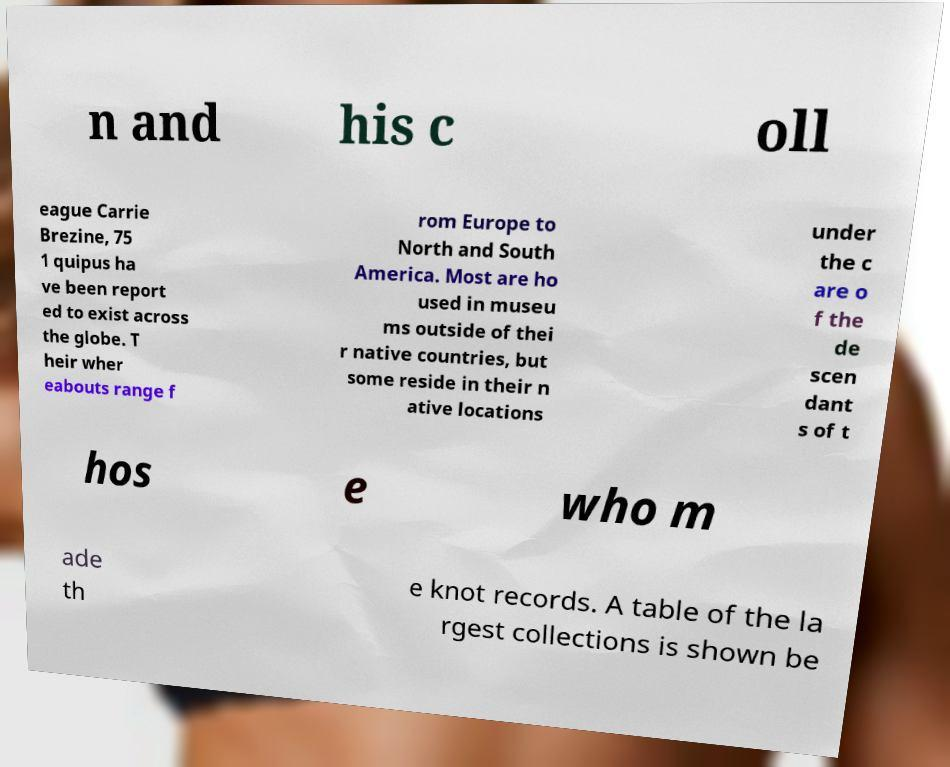Please identify and transcribe the text found in this image. n and his c oll eague Carrie Brezine, 75 1 quipus ha ve been report ed to exist across the globe. T heir wher eabouts range f rom Europe to North and South America. Most are ho used in museu ms outside of thei r native countries, but some reside in their n ative locations under the c are o f the de scen dant s of t hos e who m ade th e knot records. A table of the la rgest collections is shown be 